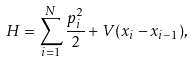<formula> <loc_0><loc_0><loc_500><loc_500>H = \sum _ { i = 1 } ^ { N } { \frac { p _ { i } ^ { 2 } } { 2 } } + V ( x _ { i } - x _ { i - 1 } ) ,</formula> 